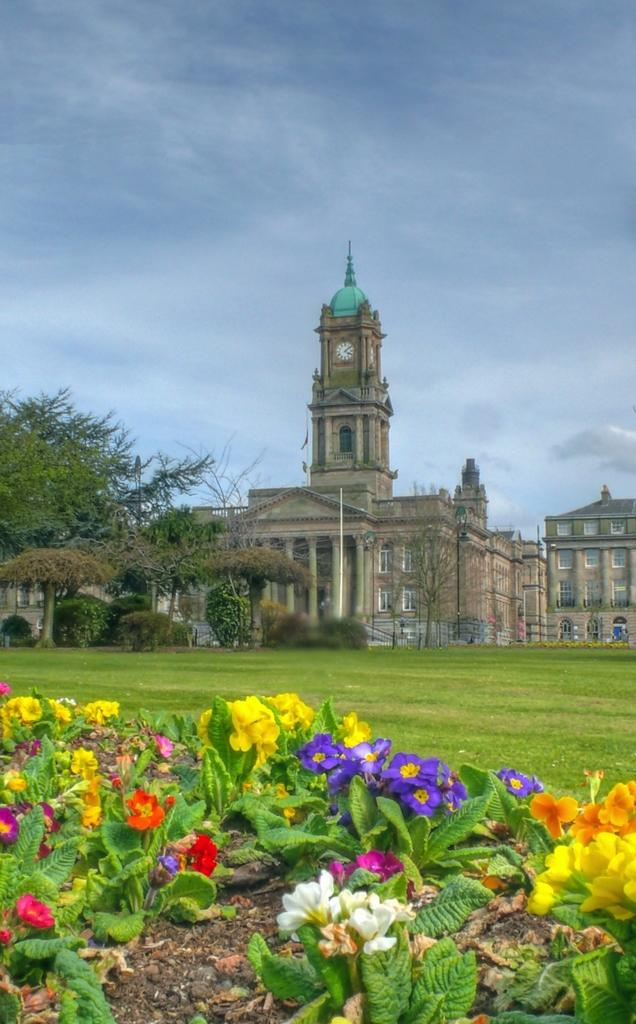What types of plants can be seen in the image? There are flowers of different colors in the image. What type of vegetation is present on the ground? There is grass in the image. What other types of plants are visible in the image? There are trees in the image. What can be seen in the background of the image? The sky is visible in the background of the image. What is the condition of the sky in the image? There are clouds in the sky. Can you describe the buildings in the image? There are buildings with windows in the image. What type of rail can be seen connecting the flowers in the image? There is no rail present in the image; it features flowers, grass, trees, buildings, and a sky with clouds. What record is being played by the flowers in the image? There is no record or music-playing device present in the image. 